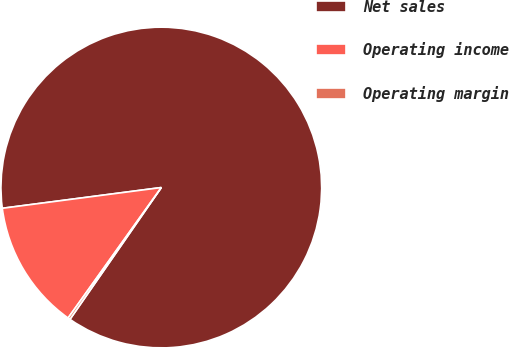<chart> <loc_0><loc_0><loc_500><loc_500><pie_chart><fcel>Net sales<fcel>Operating income<fcel>Operating margin<nl><fcel>86.71%<fcel>13.06%<fcel>0.23%<nl></chart> 